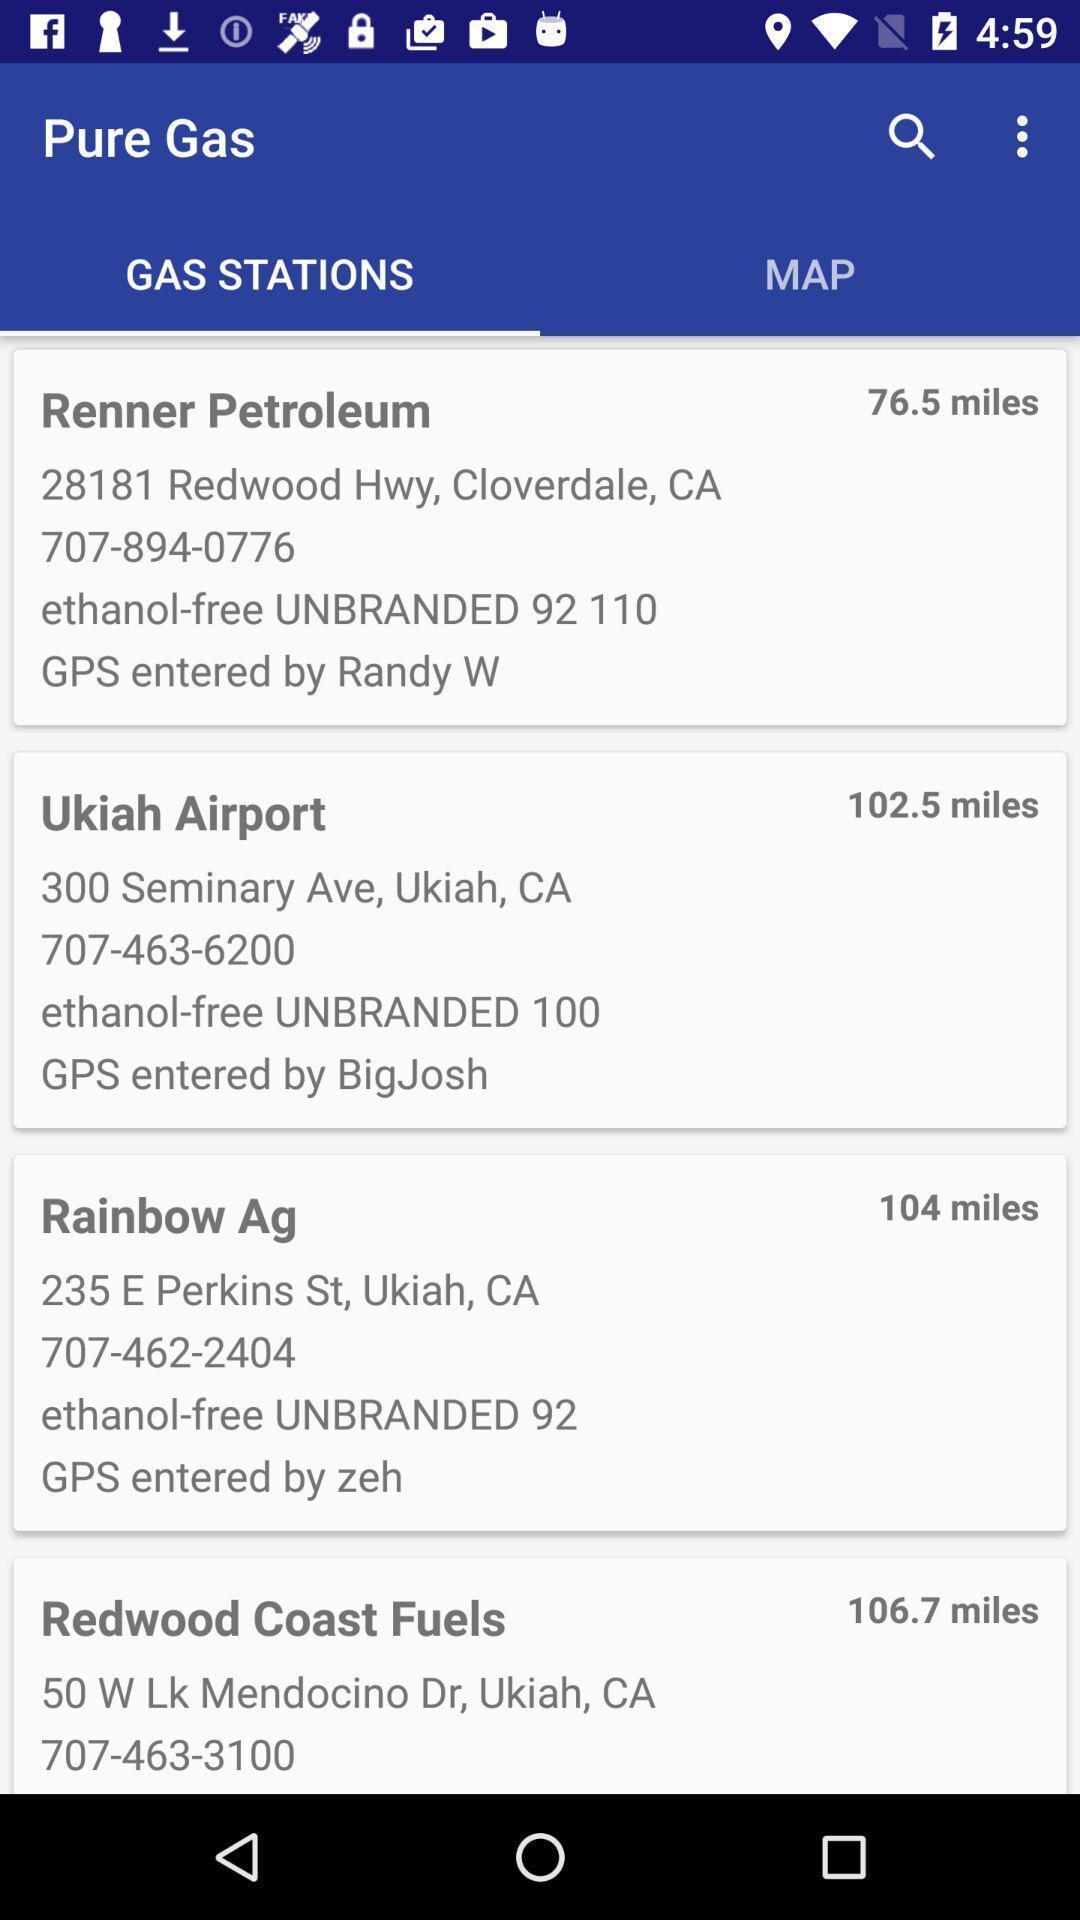Provide a detailed account of this screenshot. Page displaying various gas stations. 